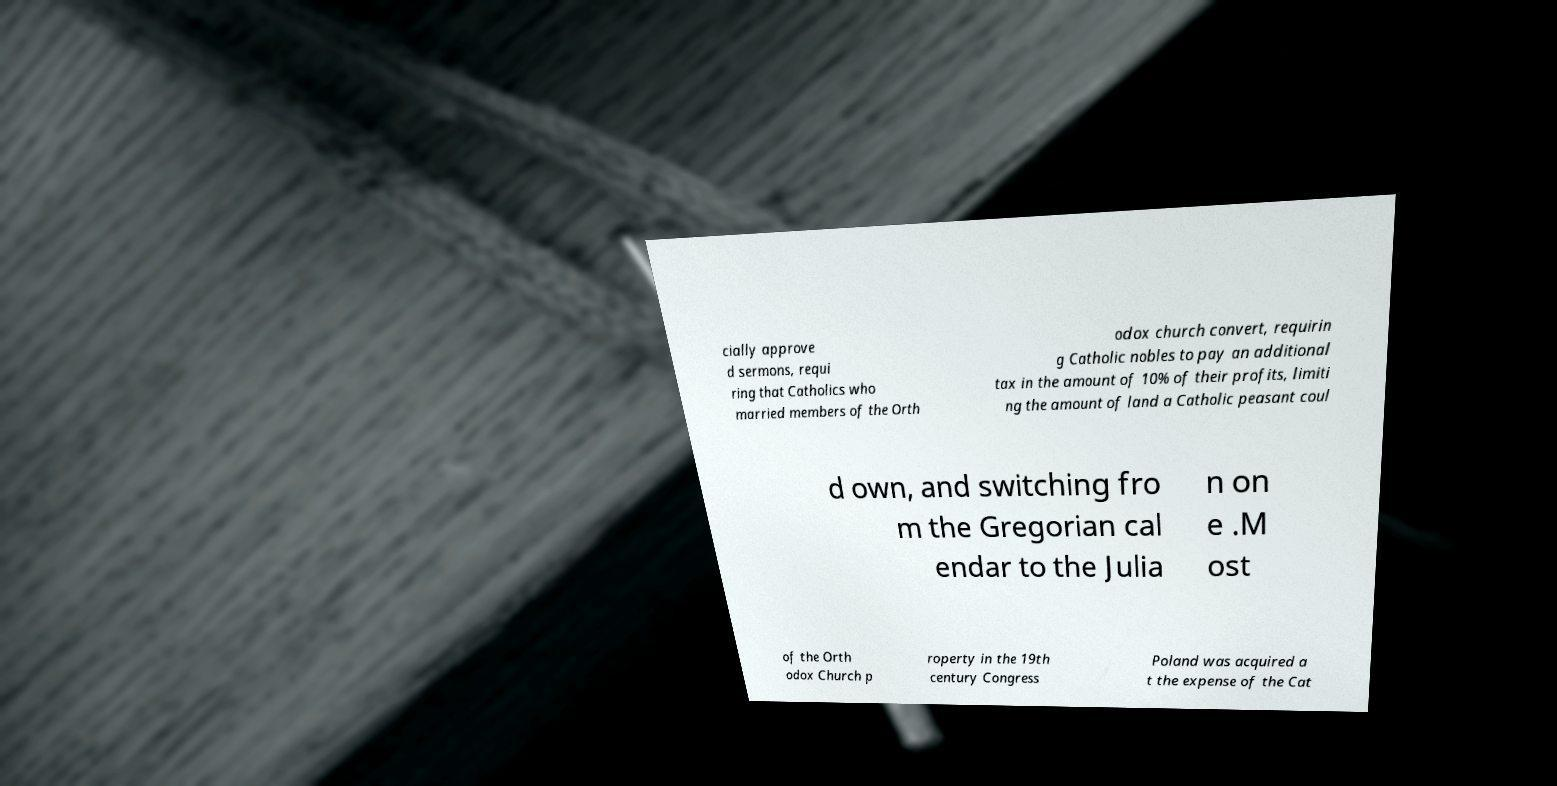Could you extract and type out the text from this image? cially approve d sermons, requi ring that Catholics who married members of the Orth odox church convert, requirin g Catholic nobles to pay an additional tax in the amount of 10% of their profits, limiti ng the amount of land a Catholic peasant coul d own, and switching fro m the Gregorian cal endar to the Julia n on e .M ost of the Orth odox Church p roperty in the 19th century Congress Poland was acquired a t the expense of the Cat 